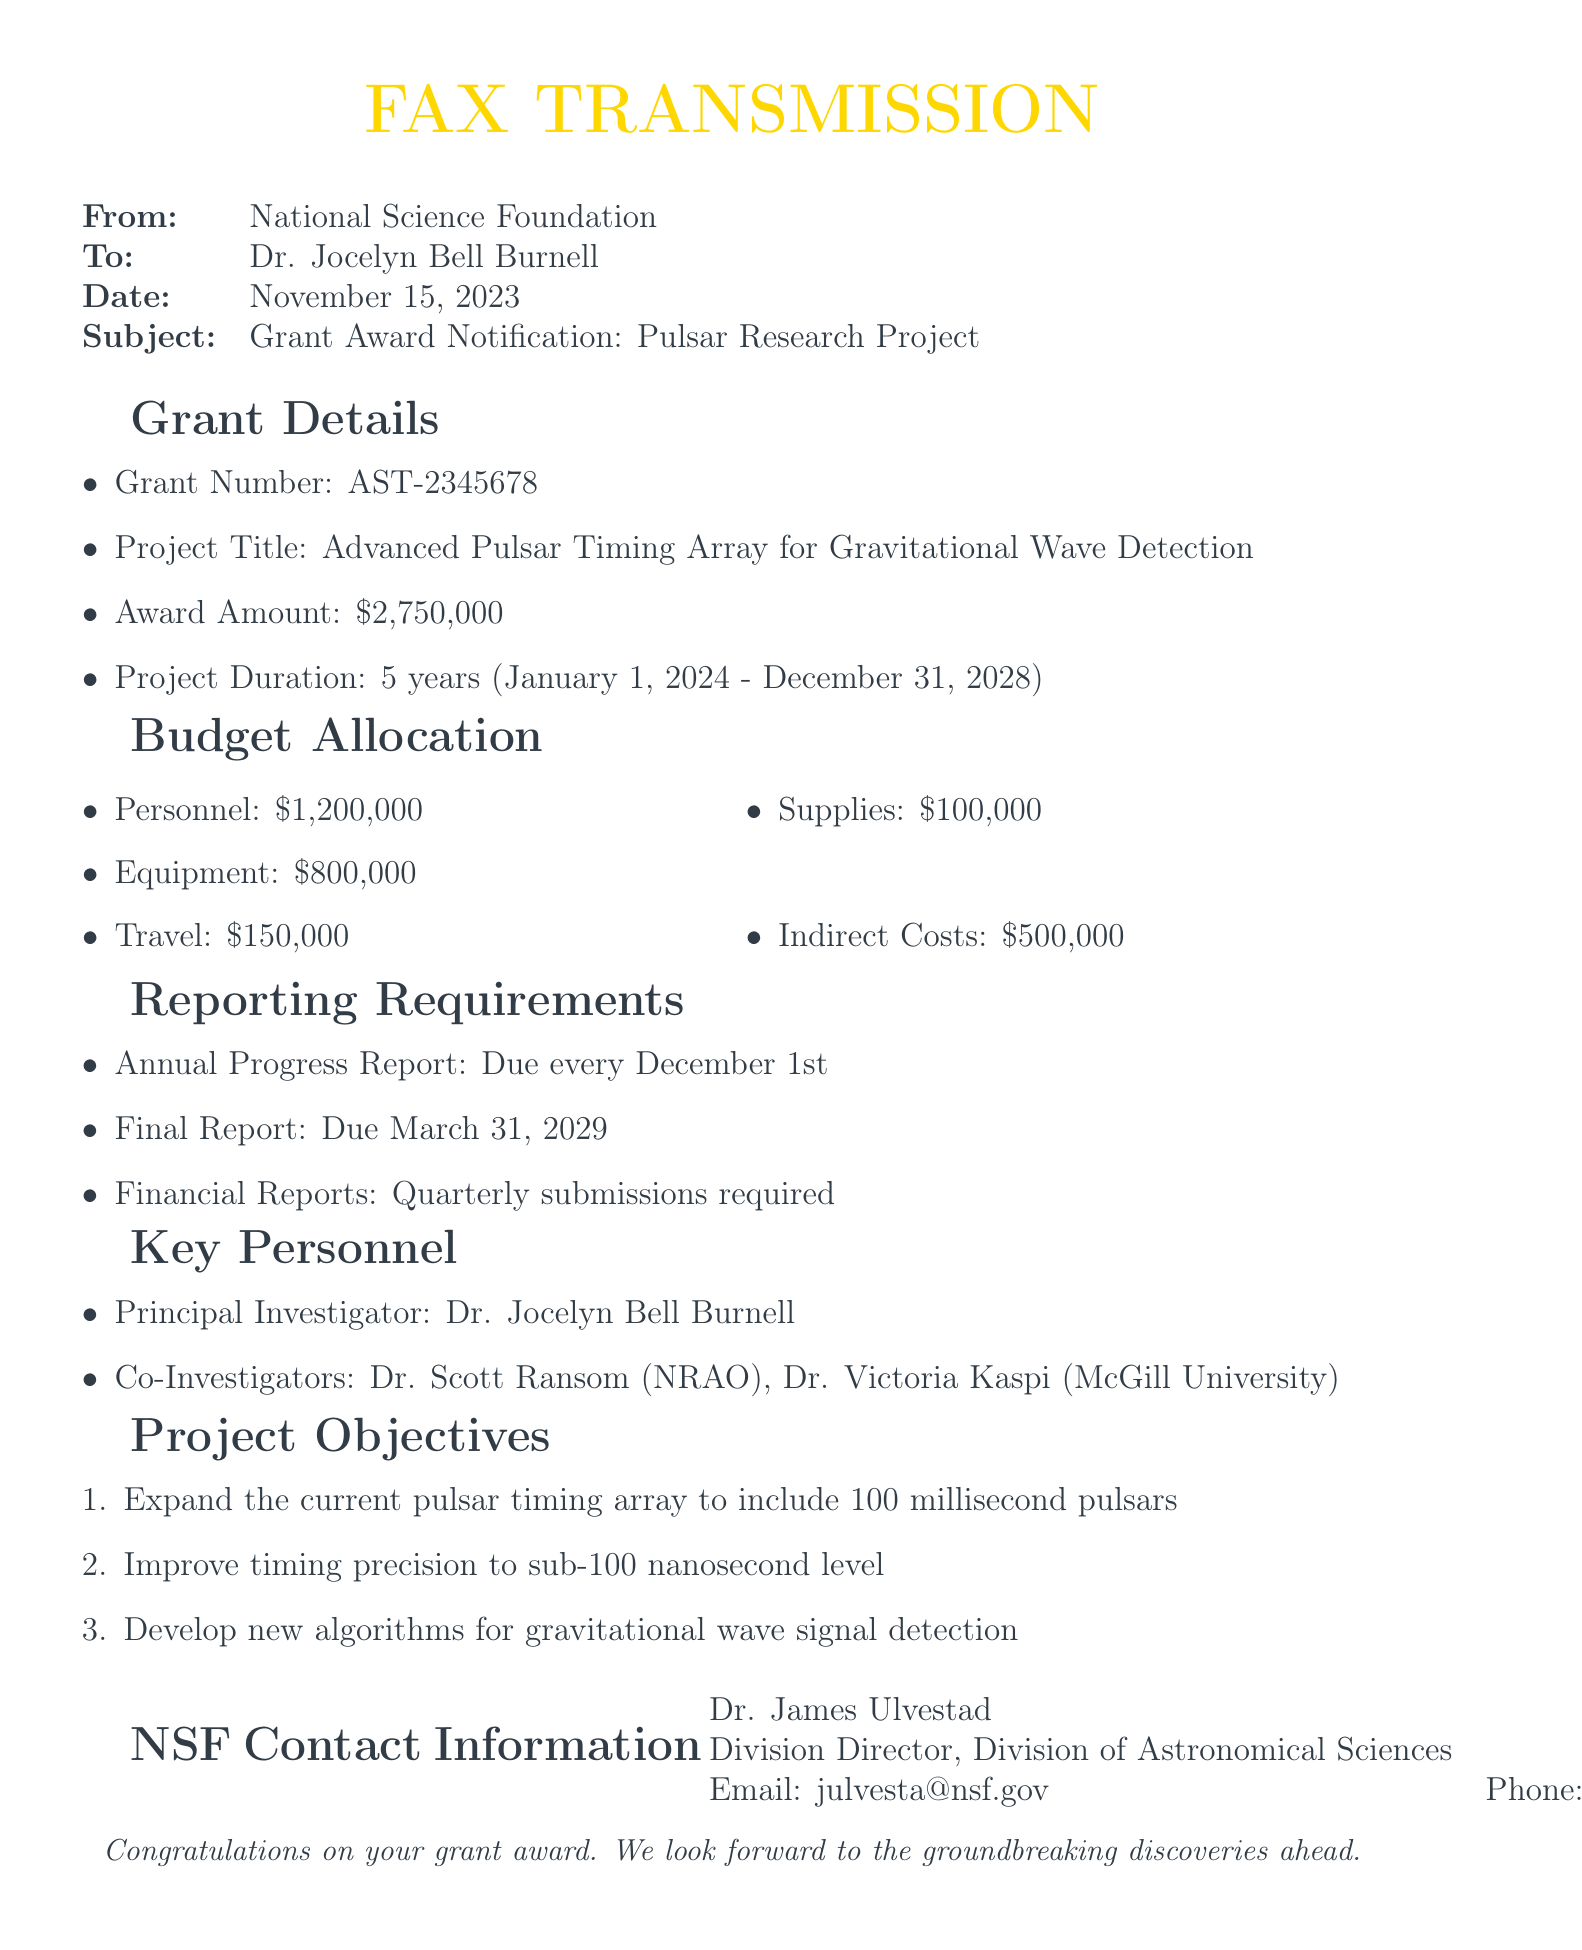What is the grant number? The grant number is clearly stated in the document as AST-2345678.
Answer: AST-2345678 What is the award amount? The document specifies the award amount as $2,750,000.
Answer: $2,750,000 Who is the Principal Investigator? The document identifies Dr. Jocelyn Bell Burnell as the Principal Investigator of the project.
Answer: Dr. Jocelyn Bell Burnell When is the final report due? According to the reporting requirements in the document, the final report is due on March 31, 2029.
Answer: March 31, 2029 What is the duration of the project? The project duration is stated as five years, from January 1, 2024, to December 31, 2028.
Answer: 5 years What is the total budget allocation for personnel? The budget allocation for personnel is mentioned as $1,200,000.
Answer: $1,200,000 Which university is Dr. Victoria Kaspi associated with? The document notes that Dr. Victoria Kaspi is associated with McGill University.
Answer: McGill University What is the purpose of the project? The key objectives outline the purpose of the project, which is to enhance pulsar timing and gravitational wave detection.
Answer: Advanced Pulsar Timing Array for Gravitational Wave Detection How often are financial reports required? The document states that financial reports are required quarterly.
Answer: Quarterly 